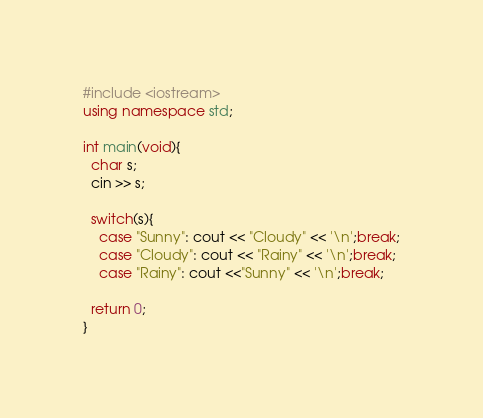Convert code to text. <code><loc_0><loc_0><loc_500><loc_500><_C++_>#include <iostream>
using namespace std;

int main(void){
  char s;
  cin >> s;
  
  switch(s){
    case "Sunny": cout << "Cloudy" << '\n';break;
    case "Cloudy": cout << "Rainy" << '\n';break;
    case "Rainy": cout <<"Sunny" << '\n';break;
  
  return 0;
}
</code> 